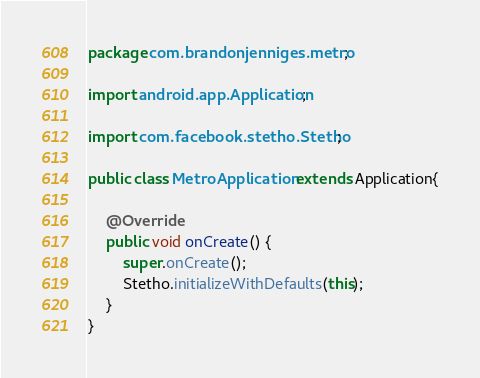Convert code to text. <code><loc_0><loc_0><loc_500><loc_500><_Java_>package com.brandonjenniges.metro;

import android.app.Application;

import com.facebook.stetho.Stetho;

public class MetroApplication extends Application{

    @Override
    public void onCreate() {
        super.onCreate();
        Stetho.initializeWithDefaults(this);
    }
}
</code> 